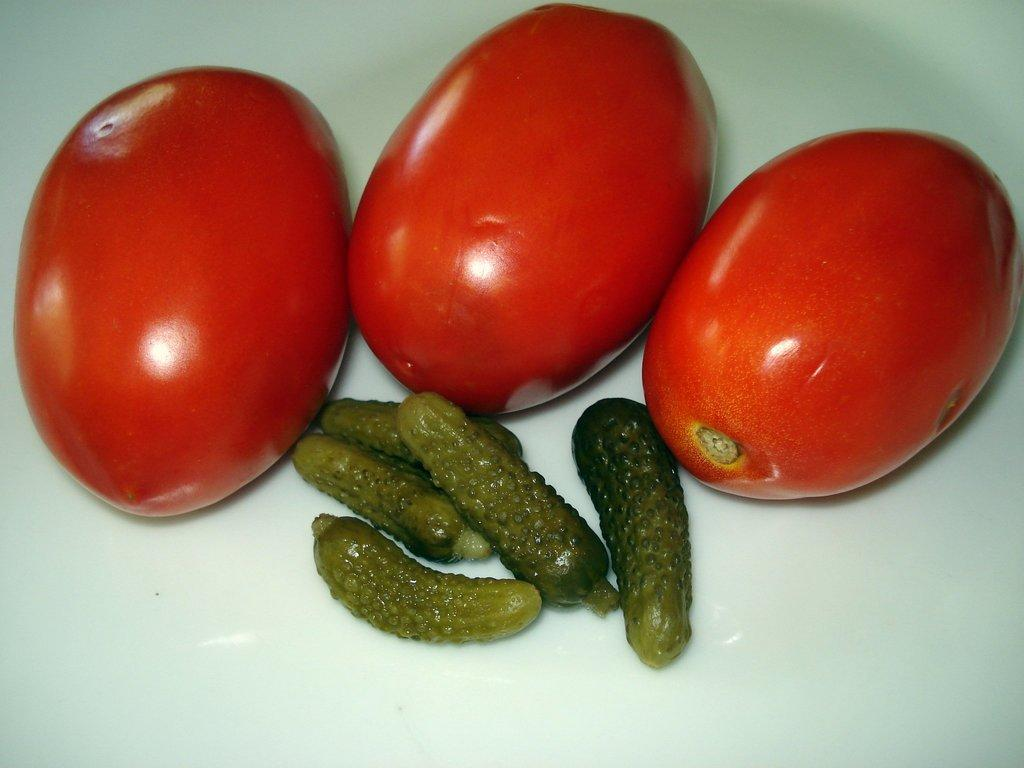What type of food can be seen in the image? There are tomatoes and pickled cucumber in the image. How are the tomatoes and pickled cucumber arranged in the image? The tomatoes and pickled cucumber are placed on a surface. What type of needle is used to sew the tomatoes and pickled cucumber together in the image? There is no needle or sewing involved in the image; it simply shows tomatoes and pickled cucumber placed on a surface. 